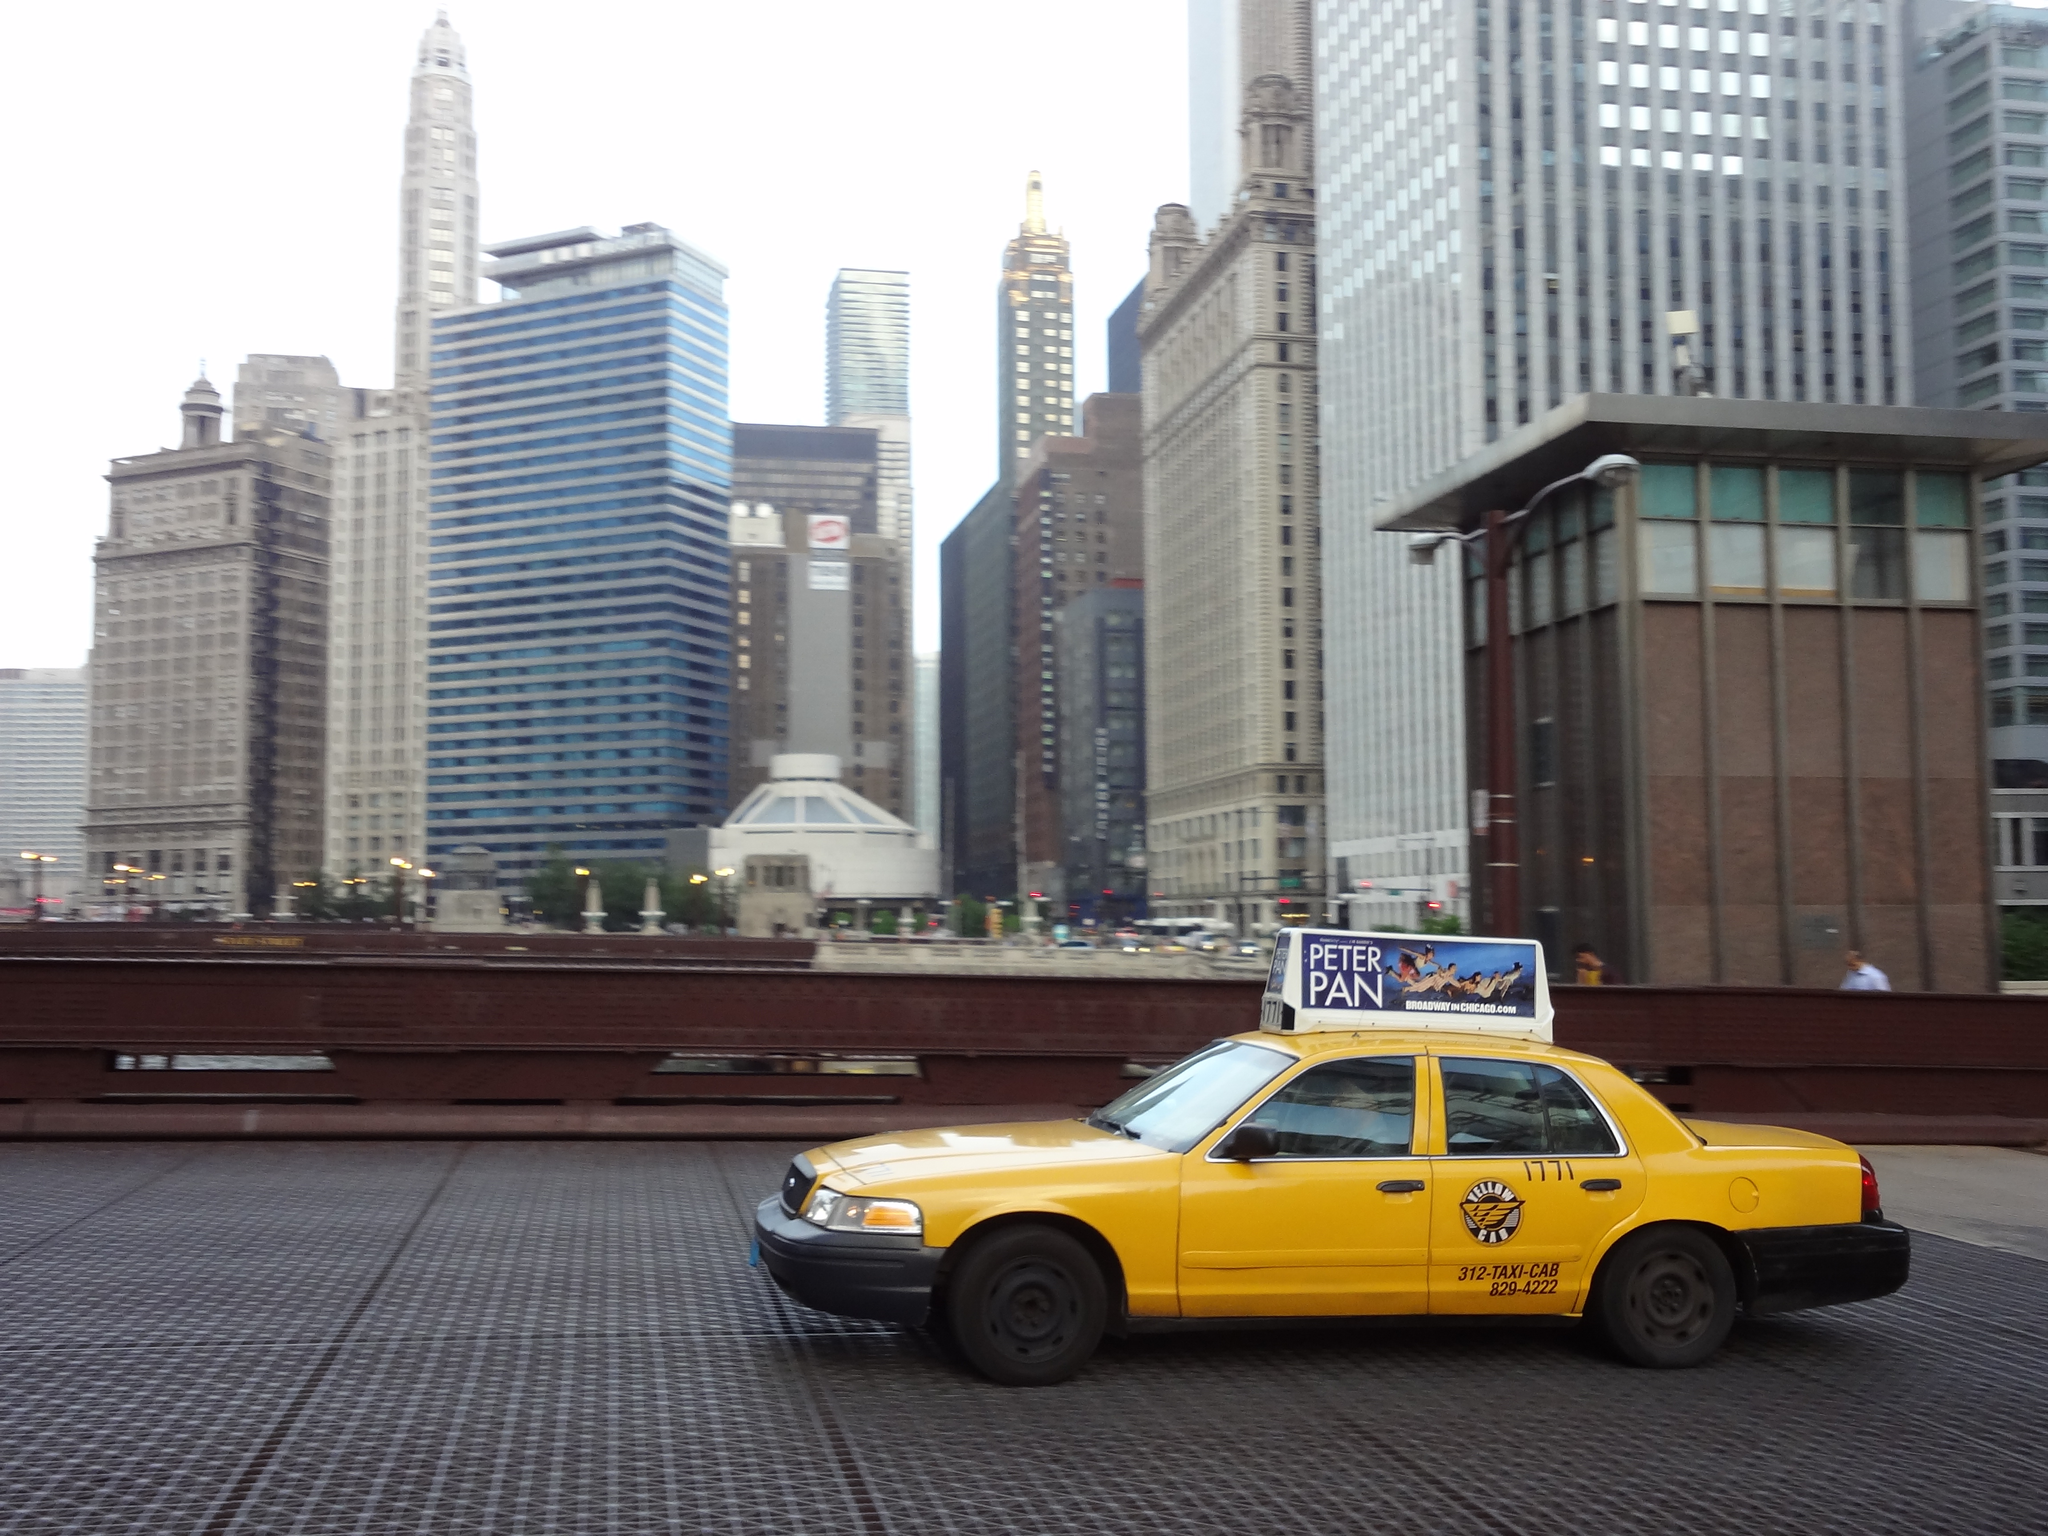<image>
Describe the image concisely. A Yellow Cab drives along with a Peter Pan advertisement on the car's roof. 